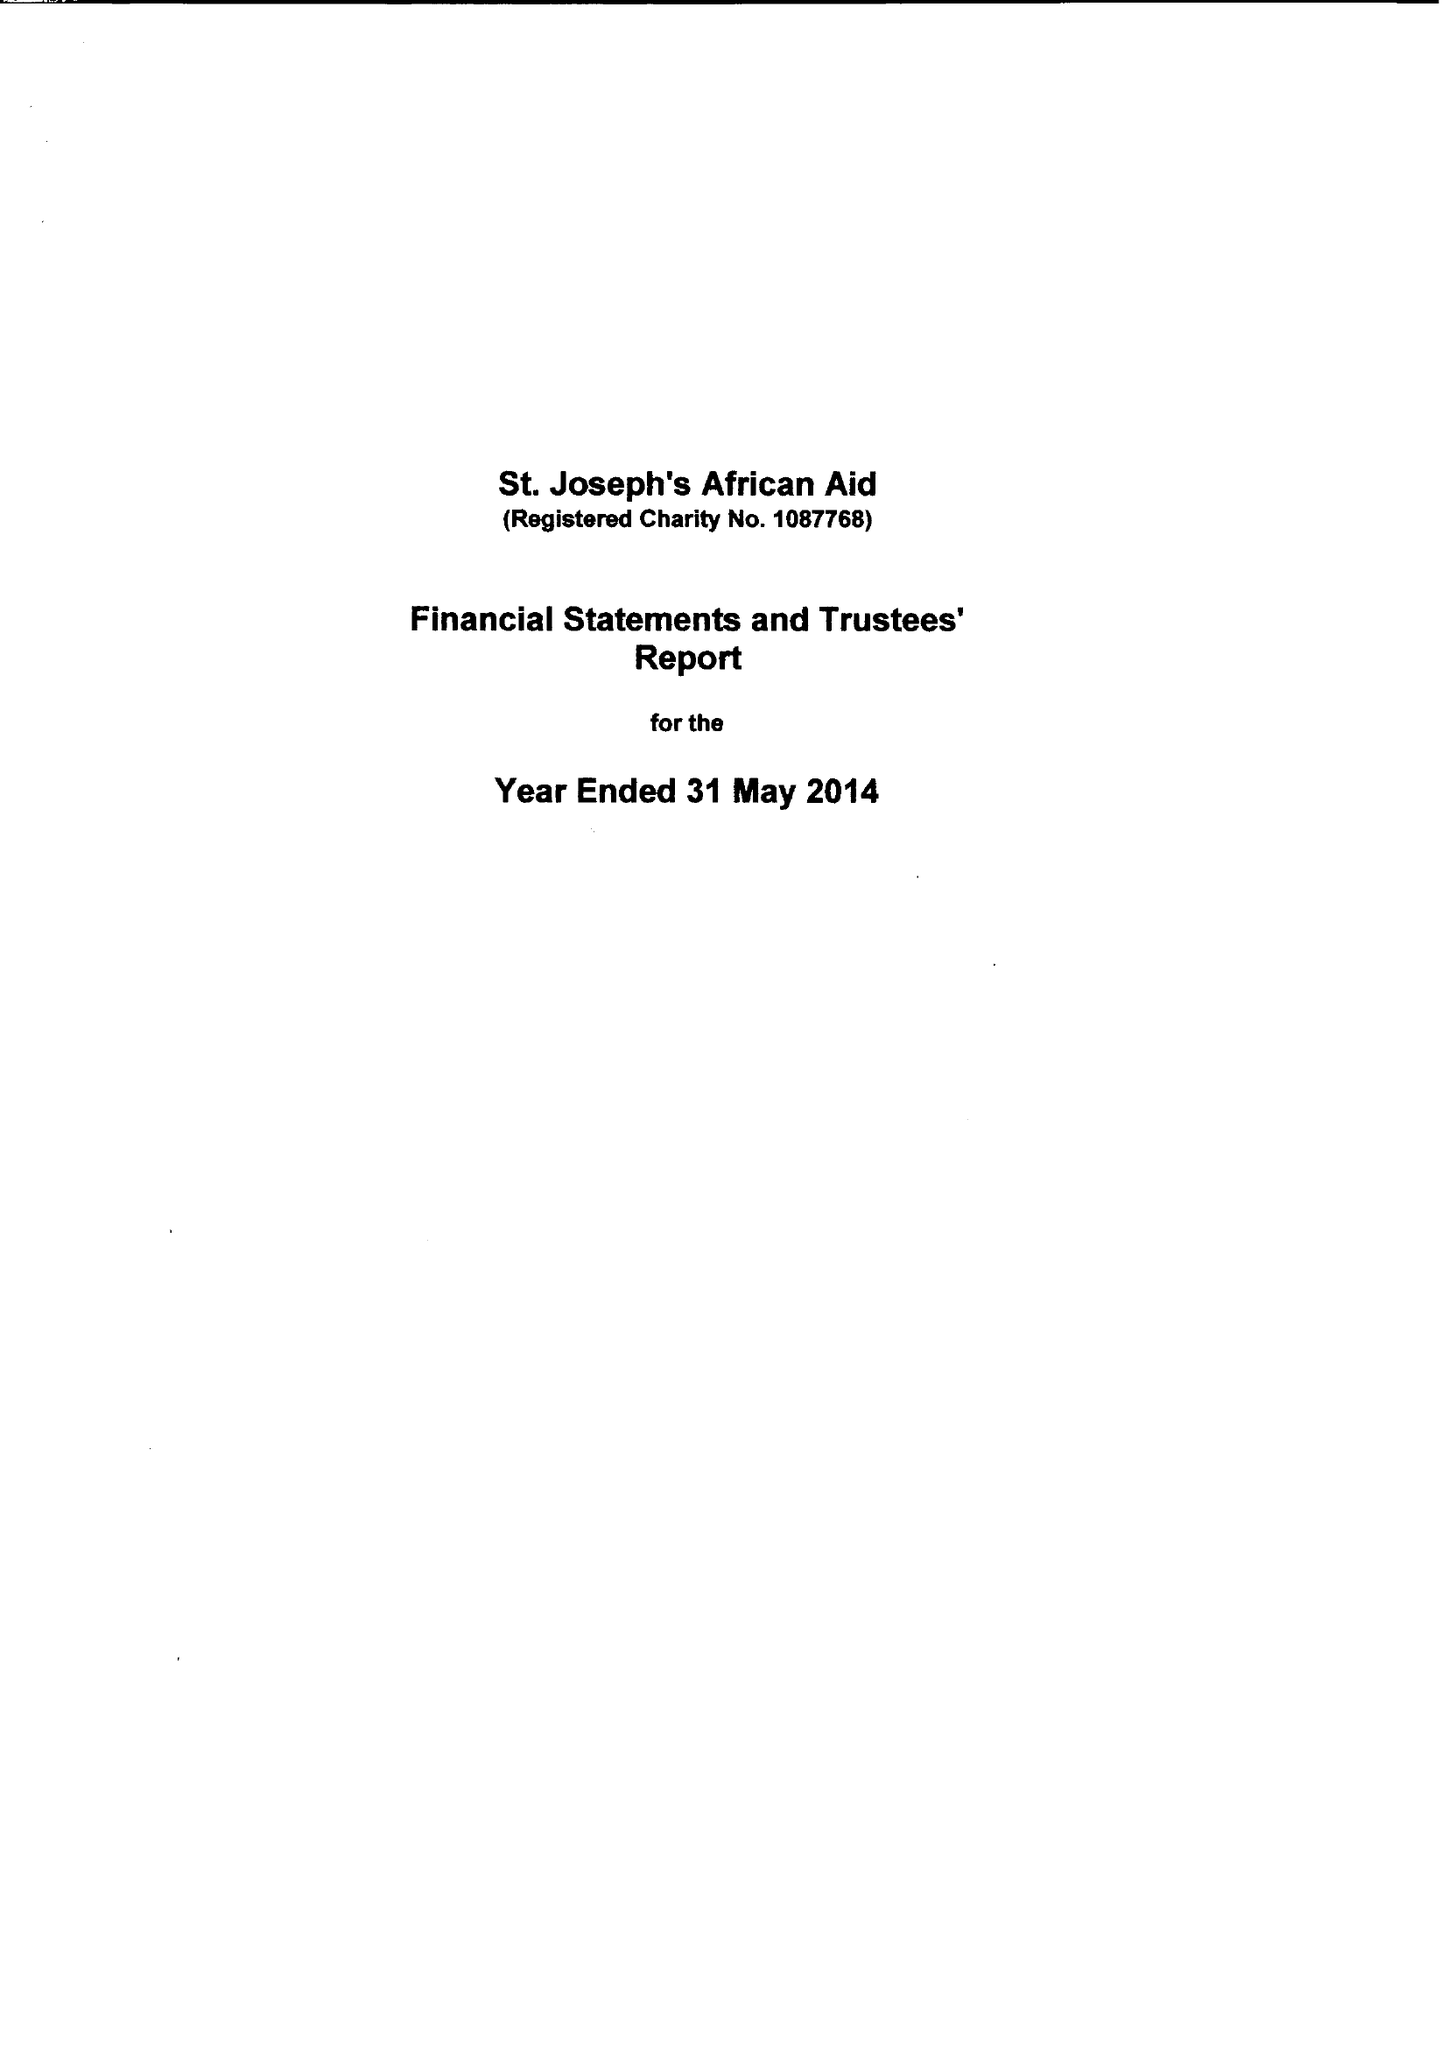What is the value for the charity_name?
Answer the question using a single word or phrase. St Joseph's African Aid 